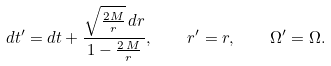Convert formula to latex. <formula><loc_0><loc_0><loc_500><loc_500>d t ^ { \prime } = d t + \frac { \sqrt { \frac { 2 M } { r } } \, d r } { 1 - \frac { 2 \, M } { r } } , \quad r ^ { \prime } = r , \quad \Omega ^ { \prime } = \Omega .</formula> 